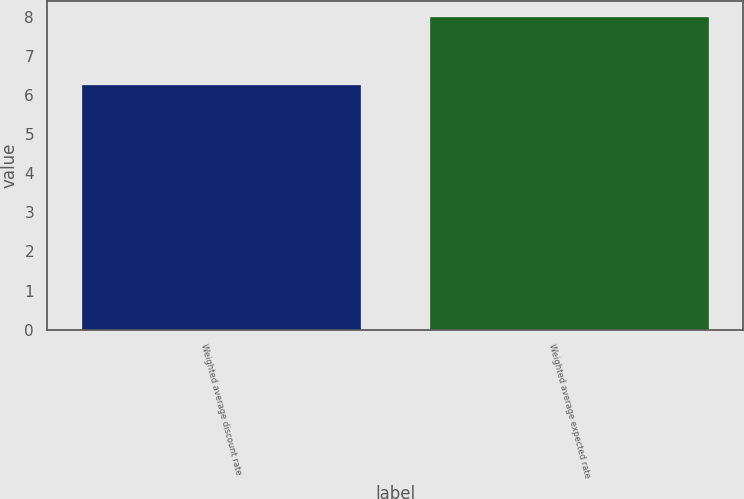Convert chart. <chart><loc_0><loc_0><loc_500><loc_500><bar_chart><fcel>Weighted average discount rate<fcel>Weighted average expected rate<nl><fcel>6.25<fcel>8<nl></chart> 